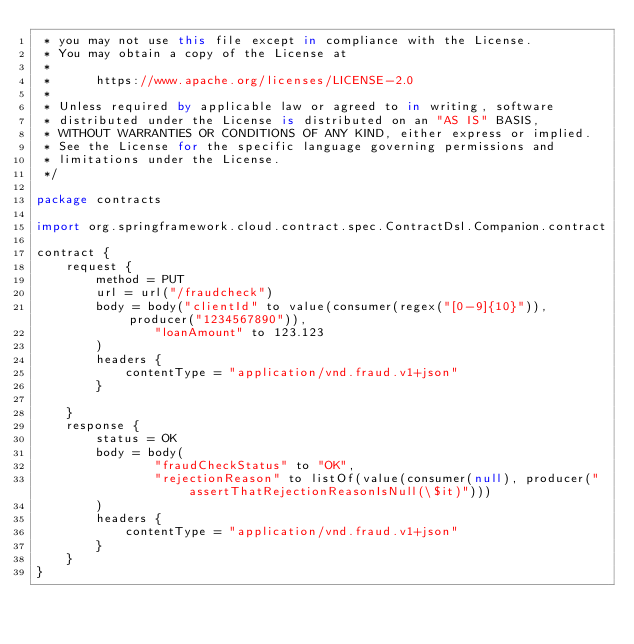Convert code to text. <code><loc_0><loc_0><loc_500><loc_500><_Kotlin_> * you may not use this file except in compliance with the License.
 * You may obtain a copy of the License at
 *
 *      https://www.apache.org/licenses/LICENSE-2.0
 *
 * Unless required by applicable law or agreed to in writing, software
 * distributed under the License is distributed on an "AS IS" BASIS,
 * WITHOUT WARRANTIES OR CONDITIONS OF ANY KIND, either express or implied.
 * See the License for the specific language governing permissions and
 * limitations under the License.
 */

package contracts

import org.springframework.cloud.contract.spec.ContractDsl.Companion.contract

contract {
    request {
        method = PUT
        url = url("/fraudcheck")
        body = body("clientId" to value(consumer(regex("[0-9]{10}")), producer("1234567890")),
                "loanAmount" to 123.123
        )
        headers {
            contentType = "application/vnd.fraud.v1+json"
        }

    }
    response {
        status = OK
        body = body(
                "fraudCheckStatus" to "OK",
                "rejectionReason" to listOf(value(consumer(null), producer("assertThatRejectionReasonIsNull(\$it)")))
        )
        headers {
            contentType = "application/vnd.fraud.v1+json"
        }
    }
}</code> 